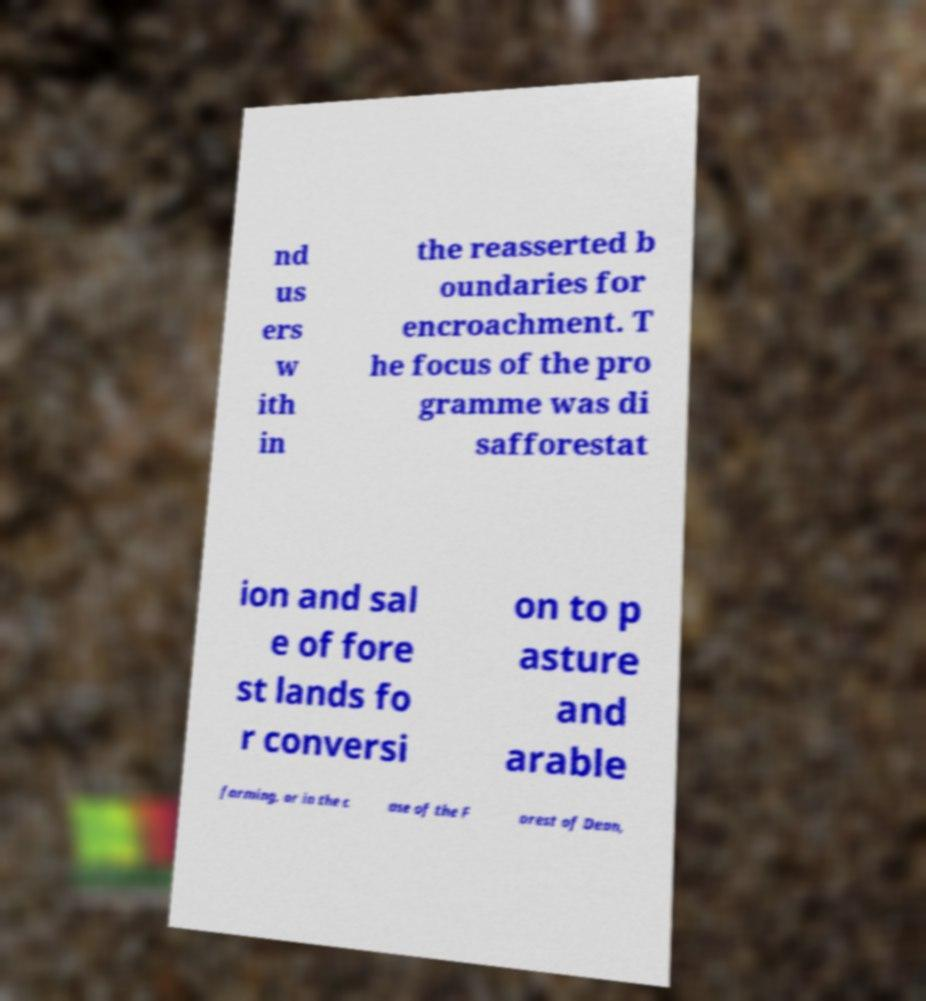For documentation purposes, I need the text within this image transcribed. Could you provide that? nd us ers w ith in the reasserted b oundaries for encroachment. T he focus of the pro gramme was di safforestat ion and sal e of fore st lands fo r conversi on to p asture and arable farming, or in the c ase of the F orest of Dean, 